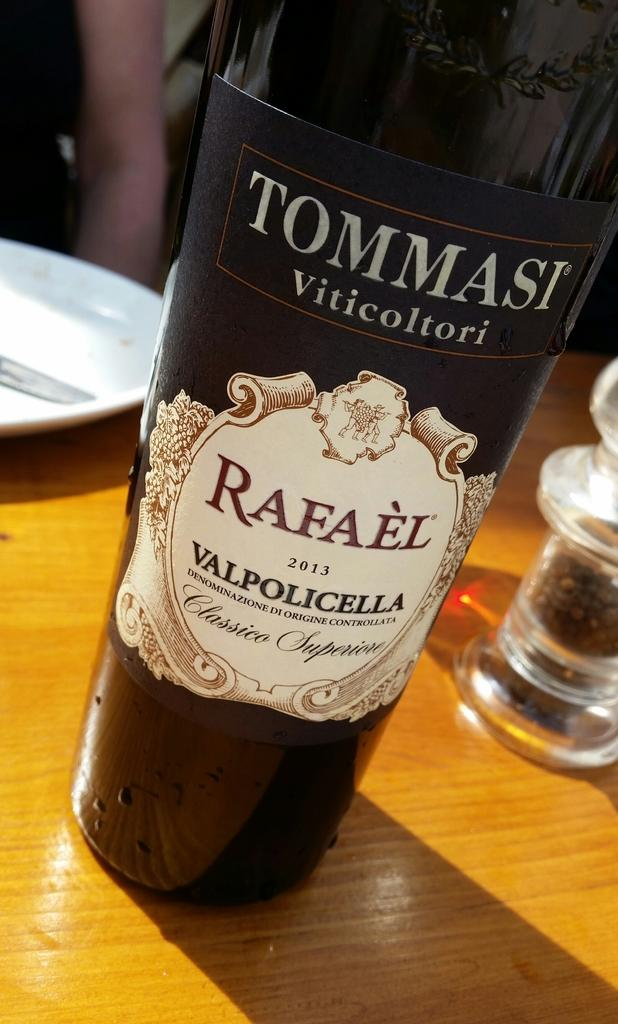What type of beverage container is in the image? There is a wine bottle in the image. What else can be seen on the table in the image? There is a plate on the table in the image. Where are the wine bottle and the plate located? Both the wine bottle and the plate are on a table. What type of hospital is visible in the image? There is no hospital present in the image; it only features a wine bottle and a plate on a table. 